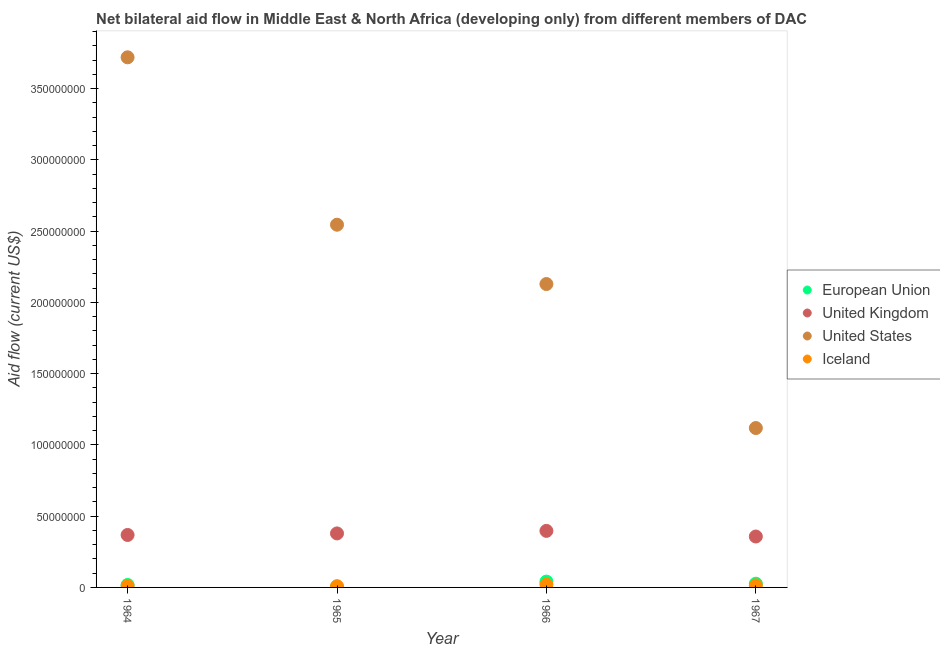What is the amount of aid given by eu in 1966?
Your response must be concise. 4.08e+06. Across all years, what is the maximum amount of aid given by us?
Your response must be concise. 3.72e+08. Across all years, what is the minimum amount of aid given by us?
Ensure brevity in your answer.  1.12e+08. In which year was the amount of aid given by us maximum?
Your answer should be very brief. 1964. In which year was the amount of aid given by uk minimum?
Your response must be concise. 1967. What is the total amount of aid given by us in the graph?
Make the answer very short. 9.51e+08. What is the difference between the amount of aid given by uk in 1964 and that in 1967?
Keep it short and to the point. 1.08e+06. What is the difference between the amount of aid given by uk in 1966 and the amount of aid given by us in 1964?
Your response must be concise. -3.32e+08. What is the average amount of aid given by iceland per year?
Make the answer very short. 1.36e+06. In the year 1967, what is the difference between the amount of aid given by us and amount of aid given by uk?
Your response must be concise. 7.61e+07. In how many years, is the amount of aid given by iceland greater than 140000000 US$?
Ensure brevity in your answer.  0. What is the ratio of the amount of aid given by uk in 1964 to that in 1965?
Offer a very short reply. 0.97. Is the amount of aid given by uk in 1965 less than that in 1967?
Your answer should be very brief. No. Is the difference between the amount of aid given by us in 1965 and 1966 greater than the difference between the amount of aid given by iceland in 1965 and 1966?
Offer a very short reply. Yes. What is the difference between the highest and the second highest amount of aid given by us?
Give a very brief answer. 1.17e+08. What is the difference between the highest and the lowest amount of aid given by eu?
Offer a very short reply. 3.86e+06. In how many years, is the amount of aid given by uk greater than the average amount of aid given by uk taken over all years?
Keep it short and to the point. 2. Is the sum of the amount of aid given by us in 1964 and 1965 greater than the maximum amount of aid given by iceland across all years?
Ensure brevity in your answer.  Yes. Is it the case that in every year, the sum of the amount of aid given by eu and amount of aid given by uk is greater than the amount of aid given by us?
Your answer should be very brief. No. Does the amount of aid given by iceland monotonically increase over the years?
Offer a very short reply. No. Is the amount of aid given by uk strictly less than the amount of aid given by us over the years?
Make the answer very short. Yes. How many dotlines are there?
Provide a short and direct response. 4. Are the values on the major ticks of Y-axis written in scientific E-notation?
Offer a very short reply. No. Does the graph contain grids?
Your answer should be very brief. No. Where does the legend appear in the graph?
Provide a succinct answer. Center right. How many legend labels are there?
Provide a succinct answer. 4. How are the legend labels stacked?
Your response must be concise. Vertical. What is the title of the graph?
Your response must be concise. Net bilateral aid flow in Middle East & North Africa (developing only) from different members of DAC. Does "Arable land" appear as one of the legend labels in the graph?
Keep it short and to the point. No. What is the label or title of the Y-axis?
Offer a terse response. Aid flow (current US$). What is the Aid flow (current US$) in European Union in 1964?
Provide a succinct answer. 1.71e+06. What is the Aid flow (current US$) in United Kingdom in 1964?
Offer a very short reply. 3.68e+07. What is the Aid flow (current US$) of United States in 1964?
Ensure brevity in your answer.  3.72e+08. What is the Aid flow (current US$) of Iceland in 1964?
Provide a succinct answer. 1.10e+06. What is the Aid flow (current US$) in European Union in 1965?
Provide a short and direct response. 2.20e+05. What is the Aid flow (current US$) of United Kingdom in 1965?
Make the answer very short. 3.79e+07. What is the Aid flow (current US$) in United States in 1965?
Your response must be concise. 2.55e+08. What is the Aid flow (current US$) in Iceland in 1965?
Make the answer very short. 8.70e+05. What is the Aid flow (current US$) of European Union in 1966?
Keep it short and to the point. 4.08e+06. What is the Aid flow (current US$) of United Kingdom in 1966?
Keep it short and to the point. 3.97e+07. What is the Aid flow (current US$) of United States in 1966?
Your answer should be very brief. 2.13e+08. What is the Aid flow (current US$) in Iceland in 1966?
Offer a very short reply. 2.01e+06. What is the Aid flow (current US$) in European Union in 1967?
Your answer should be very brief. 2.62e+06. What is the Aid flow (current US$) of United Kingdom in 1967?
Your response must be concise. 3.57e+07. What is the Aid flow (current US$) in United States in 1967?
Make the answer very short. 1.12e+08. What is the Aid flow (current US$) in Iceland in 1967?
Your response must be concise. 1.44e+06. Across all years, what is the maximum Aid flow (current US$) in European Union?
Provide a succinct answer. 4.08e+06. Across all years, what is the maximum Aid flow (current US$) of United Kingdom?
Offer a very short reply. 3.97e+07. Across all years, what is the maximum Aid flow (current US$) of United States?
Your response must be concise. 3.72e+08. Across all years, what is the maximum Aid flow (current US$) in Iceland?
Give a very brief answer. 2.01e+06. Across all years, what is the minimum Aid flow (current US$) of United Kingdom?
Provide a succinct answer. 3.57e+07. Across all years, what is the minimum Aid flow (current US$) in United States?
Offer a very short reply. 1.12e+08. Across all years, what is the minimum Aid flow (current US$) in Iceland?
Offer a terse response. 8.70e+05. What is the total Aid flow (current US$) in European Union in the graph?
Provide a succinct answer. 8.63e+06. What is the total Aid flow (current US$) in United Kingdom in the graph?
Make the answer very short. 1.50e+08. What is the total Aid flow (current US$) in United States in the graph?
Offer a very short reply. 9.51e+08. What is the total Aid flow (current US$) of Iceland in the graph?
Keep it short and to the point. 5.42e+06. What is the difference between the Aid flow (current US$) in European Union in 1964 and that in 1965?
Make the answer very short. 1.49e+06. What is the difference between the Aid flow (current US$) in United Kingdom in 1964 and that in 1965?
Ensure brevity in your answer.  -1.09e+06. What is the difference between the Aid flow (current US$) of United States in 1964 and that in 1965?
Provide a short and direct response. 1.17e+08. What is the difference between the Aid flow (current US$) of Iceland in 1964 and that in 1965?
Offer a very short reply. 2.30e+05. What is the difference between the Aid flow (current US$) of European Union in 1964 and that in 1966?
Offer a terse response. -2.37e+06. What is the difference between the Aid flow (current US$) of United Kingdom in 1964 and that in 1966?
Offer a very short reply. -2.87e+06. What is the difference between the Aid flow (current US$) of United States in 1964 and that in 1966?
Your response must be concise. 1.59e+08. What is the difference between the Aid flow (current US$) of Iceland in 1964 and that in 1966?
Offer a very short reply. -9.10e+05. What is the difference between the Aid flow (current US$) of European Union in 1964 and that in 1967?
Your answer should be compact. -9.10e+05. What is the difference between the Aid flow (current US$) in United Kingdom in 1964 and that in 1967?
Your answer should be compact. 1.08e+06. What is the difference between the Aid flow (current US$) in United States in 1964 and that in 1967?
Make the answer very short. 2.60e+08. What is the difference between the Aid flow (current US$) in European Union in 1965 and that in 1966?
Offer a terse response. -3.86e+06. What is the difference between the Aid flow (current US$) of United Kingdom in 1965 and that in 1966?
Keep it short and to the point. -1.78e+06. What is the difference between the Aid flow (current US$) in United States in 1965 and that in 1966?
Provide a succinct answer. 4.16e+07. What is the difference between the Aid flow (current US$) of Iceland in 1965 and that in 1966?
Give a very brief answer. -1.14e+06. What is the difference between the Aid flow (current US$) in European Union in 1965 and that in 1967?
Give a very brief answer. -2.40e+06. What is the difference between the Aid flow (current US$) in United Kingdom in 1965 and that in 1967?
Offer a terse response. 2.17e+06. What is the difference between the Aid flow (current US$) of United States in 1965 and that in 1967?
Offer a terse response. 1.43e+08. What is the difference between the Aid flow (current US$) of Iceland in 1965 and that in 1967?
Ensure brevity in your answer.  -5.70e+05. What is the difference between the Aid flow (current US$) in European Union in 1966 and that in 1967?
Offer a terse response. 1.46e+06. What is the difference between the Aid flow (current US$) in United Kingdom in 1966 and that in 1967?
Ensure brevity in your answer.  3.95e+06. What is the difference between the Aid flow (current US$) of United States in 1966 and that in 1967?
Your response must be concise. 1.01e+08. What is the difference between the Aid flow (current US$) in Iceland in 1966 and that in 1967?
Your answer should be very brief. 5.70e+05. What is the difference between the Aid flow (current US$) in European Union in 1964 and the Aid flow (current US$) in United Kingdom in 1965?
Make the answer very short. -3.62e+07. What is the difference between the Aid flow (current US$) in European Union in 1964 and the Aid flow (current US$) in United States in 1965?
Your response must be concise. -2.53e+08. What is the difference between the Aid flow (current US$) of European Union in 1964 and the Aid flow (current US$) of Iceland in 1965?
Your answer should be compact. 8.40e+05. What is the difference between the Aid flow (current US$) in United Kingdom in 1964 and the Aid flow (current US$) in United States in 1965?
Make the answer very short. -2.18e+08. What is the difference between the Aid flow (current US$) of United Kingdom in 1964 and the Aid flow (current US$) of Iceland in 1965?
Give a very brief answer. 3.59e+07. What is the difference between the Aid flow (current US$) of United States in 1964 and the Aid flow (current US$) of Iceland in 1965?
Provide a short and direct response. 3.71e+08. What is the difference between the Aid flow (current US$) of European Union in 1964 and the Aid flow (current US$) of United Kingdom in 1966?
Provide a short and direct response. -3.80e+07. What is the difference between the Aid flow (current US$) in European Union in 1964 and the Aid flow (current US$) in United States in 1966?
Give a very brief answer. -2.11e+08. What is the difference between the Aid flow (current US$) in European Union in 1964 and the Aid flow (current US$) in Iceland in 1966?
Give a very brief answer. -3.00e+05. What is the difference between the Aid flow (current US$) in United Kingdom in 1964 and the Aid flow (current US$) in United States in 1966?
Your response must be concise. -1.76e+08. What is the difference between the Aid flow (current US$) in United Kingdom in 1964 and the Aid flow (current US$) in Iceland in 1966?
Provide a short and direct response. 3.48e+07. What is the difference between the Aid flow (current US$) in United States in 1964 and the Aid flow (current US$) in Iceland in 1966?
Make the answer very short. 3.70e+08. What is the difference between the Aid flow (current US$) of European Union in 1964 and the Aid flow (current US$) of United Kingdom in 1967?
Offer a very short reply. -3.40e+07. What is the difference between the Aid flow (current US$) in European Union in 1964 and the Aid flow (current US$) in United States in 1967?
Provide a succinct answer. -1.10e+08. What is the difference between the Aid flow (current US$) in United Kingdom in 1964 and the Aid flow (current US$) in United States in 1967?
Give a very brief answer. -7.50e+07. What is the difference between the Aid flow (current US$) in United Kingdom in 1964 and the Aid flow (current US$) in Iceland in 1967?
Offer a terse response. 3.54e+07. What is the difference between the Aid flow (current US$) of United States in 1964 and the Aid flow (current US$) of Iceland in 1967?
Make the answer very short. 3.71e+08. What is the difference between the Aid flow (current US$) in European Union in 1965 and the Aid flow (current US$) in United Kingdom in 1966?
Make the answer very short. -3.95e+07. What is the difference between the Aid flow (current US$) of European Union in 1965 and the Aid flow (current US$) of United States in 1966?
Your answer should be compact. -2.13e+08. What is the difference between the Aid flow (current US$) of European Union in 1965 and the Aid flow (current US$) of Iceland in 1966?
Ensure brevity in your answer.  -1.79e+06. What is the difference between the Aid flow (current US$) in United Kingdom in 1965 and the Aid flow (current US$) in United States in 1966?
Your answer should be very brief. -1.75e+08. What is the difference between the Aid flow (current US$) in United Kingdom in 1965 and the Aid flow (current US$) in Iceland in 1966?
Your answer should be very brief. 3.59e+07. What is the difference between the Aid flow (current US$) of United States in 1965 and the Aid flow (current US$) of Iceland in 1966?
Your answer should be very brief. 2.53e+08. What is the difference between the Aid flow (current US$) of European Union in 1965 and the Aid flow (current US$) of United Kingdom in 1967?
Ensure brevity in your answer.  -3.55e+07. What is the difference between the Aid flow (current US$) in European Union in 1965 and the Aid flow (current US$) in United States in 1967?
Your answer should be very brief. -1.12e+08. What is the difference between the Aid flow (current US$) of European Union in 1965 and the Aid flow (current US$) of Iceland in 1967?
Provide a short and direct response. -1.22e+06. What is the difference between the Aid flow (current US$) in United Kingdom in 1965 and the Aid flow (current US$) in United States in 1967?
Make the answer very short. -7.40e+07. What is the difference between the Aid flow (current US$) of United Kingdom in 1965 and the Aid flow (current US$) of Iceland in 1967?
Offer a terse response. 3.65e+07. What is the difference between the Aid flow (current US$) in United States in 1965 and the Aid flow (current US$) in Iceland in 1967?
Your answer should be very brief. 2.53e+08. What is the difference between the Aid flow (current US$) of European Union in 1966 and the Aid flow (current US$) of United Kingdom in 1967?
Give a very brief answer. -3.16e+07. What is the difference between the Aid flow (current US$) of European Union in 1966 and the Aid flow (current US$) of United States in 1967?
Provide a short and direct response. -1.08e+08. What is the difference between the Aid flow (current US$) in European Union in 1966 and the Aid flow (current US$) in Iceland in 1967?
Offer a terse response. 2.64e+06. What is the difference between the Aid flow (current US$) of United Kingdom in 1966 and the Aid flow (current US$) of United States in 1967?
Make the answer very short. -7.22e+07. What is the difference between the Aid flow (current US$) of United Kingdom in 1966 and the Aid flow (current US$) of Iceland in 1967?
Keep it short and to the point. 3.82e+07. What is the difference between the Aid flow (current US$) in United States in 1966 and the Aid flow (current US$) in Iceland in 1967?
Your response must be concise. 2.11e+08. What is the average Aid flow (current US$) of European Union per year?
Offer a terse response. 2.16e+06. What is the average Aid flow (current US$) in United Kingdom per year?
Give a very brief answer. 3.75e+07. What is the average Aid flow (current US$) in United States per year?
Ensure brevity in your answer.  2.38e+08. What is the average Aid flow (current US$) in Iceland per year?
Keep it short and to the point. 1.36e+06. In the year 1964, what is the difference between the Aid flow (current US$) of European Union and Aid flow (current US$) of United Kingdom?
Your answer should be compact. -3.51e+07. In the year 1964, what is the difference between the Aid flow (current US$) of European Union and Aid flow (current US$) of United States?
Make the answer very short. -3.70e+08. In the year 1964, what is the difference between the Aid flow (current US$) of European Union and Aid flow (current US$) of Iceland?
Ensure brevity in your answer.  6.10e+05. In the year 1964, what is the difference between the Aid flow (current US$) in United Kingdom and Aid flow (current US$) in United States?
Keep it short and to the point. -3.35e+08. In the year 1964, what is the difference between the Aid flow (current US$) of United Kingdom and Aid flow (current US$) of Iceland?
Your answer should be very brief. 3.57e+07. In the year 1964, what is the difference between the Aid flow (current US$) of United States and Aid flow (current US$) of Iceland?
Keep it short and to the point. 3.71e+08. In the year 1965, what is the difference between the Aid flow (current US$) in European Union and Aid flow (current US$) in United Kingdom?
Give a very brief answer. -3.77e+07. In the year 1965, what is the difference between the Aid flow (current US$) of European Union and Aid flow (current US$) of United States?
Offer a terse response. -2.54e+08. In the year 1965, what is the difference between the Aid flow (current US$) in European Union and Aid flow (current US$) in Iceland?
Make the answer very short. -6.50e+05. In the year 1965, what is the difference between the Aid flow (current US$) in United Kingdom and Aid flow (current US$) in United States?
Your response must be concise. -2.17e+08. In the year 1965, what is the difference between the Aid flow (current US$) of United Kingdom and Aid flow (current US$) of Iceland?
Your response must be concise. 3.70e+07. In the year 1965, what is the difference between the Aid flow (current US$) in United States and Aid flow (current US$) in Iceland?
Your answer should be very brief. 2.54e+08. In the year 1966, what is the difference between the Aid flow (current US$) of European Union and Aid flow (current US$) of United Kingdom?
Offer a terse response. -3.56e+07. In the year 1966, what is the difference between the Aid flow (current US$) of European Union and Aid flow (current US$) of United States?
Keep it short and to the point. -2.09e+08. In the year 1966, what is the difference between the Aid flow (current US$) of European Union and Aid flow (current US$) of Iceland?
Keep it short and to the point. 2.07e+06. In the year 1966, what is the difference between the Aid flow (current US$) in United Kingdom and Aid flow (current US$) in United States?
Ensure brevity in your answer.  -1.73e+08. In the year 1966, what is the difference between the Aid flow (current US$) in United Kingdom and Aid flow (current US$) in Iceland?
Offer a terse response. 3.77e+07. In the year 1966, what is the difference between the Aid flow (current US$) in United States and Aid flow (current US$) in Iceland?
Keep it short and to the point. 2.11e+08. In the year 1967, what is the difference between the Aid flow (current US$) of European Union and Aid flow (current US$) of United Kingdom?
Your answer should be very brief. -3.31e+07. In the year 1967, what is the difference between the Aid flow (current US$) of European Union and Aid flow (current US$) of United States?
Offer a very short reply. -1.09e+08. In the year 1967, what is the difference between the Aid flow (current US$) of European Union and Aid flow (current US$) of Iceland?
Make the answer very short. 1.18e+06. In the year 1967, what is the difference between the Aid flow (current US$) of United Kingdom and Aid flow (current US$) of United States?
Ensure brevity in your answer.  -7.61e+07. In the year 1967, what is the difference between the Aid flow (current US$) of United Kingdom and Aid flow (current US$) of Iceland?
Offer a very short reply. 3.43e+07. In the year 1967, what is the difference between the Aid flow (current US$) of United States and Aid flow (current US$) of Iceland?
Your answer should be very brief. 1.10e+08. What is the ratio of the Aid flow (current US$) in European Union in 1964 to that in 1965?
Offer a very short reply. 7.77. What is the ratio of the Aid flow (current US$) of United Kingdom in 1964 to that in 1965?
Keep it short and to the point. 0.97. What is the ratio of the Aid flow (current US$) of United States in 1964 to that in 1965?
Provide a short and direct response. 1.46. What is the ratio of the Aid flow (current US$) of Iceland in 1964 to that in 1965?
Offer a very short reply. 1.26. What is the ratio of the Aid flow (current US$) of European Union in 1964 to that in 1966?
Keep it short and to the point. 0.42. What is the ratio of the Aid flow (current US$) in United Kingdom in 1964 to that in 1966?
Keep it short and to the point. 0.93. What is the ratio of the Aid flow (current US$) of United States in 1964 to that in 1966?
Give a very brief answer. 1.75. What is the ratio of the Aid flow (current US$) in Iceland in 1964 to that in 1966?
Provide a short and direct response. 0.55. What is the ratio of the Aid flow (current US$) in European Union in 1964 to that in 1967?
Ensure brevity in your answer.  0.65. What is the ratio of the Aid flow (current US$) in United Kingdom in 1964 to that in 1967?
Your answer should be compact. 1.03. What is the ratio of the Aid flow (current US$) in United States in 1964 to that in 1967?
Provide a short and direct response. 3.33. What is the ratio of the Aid flow (current US$) of Iceland in 1964 to that in 1967?
Keep it short and to the point. 0.76. What is the ratio of the Aid flow (current US$) in European Union in 1965 to that in 1966?
Offer a terse response. 0.05. What is the ratio of the Aid flow (current US$) of United Kingdom in 1965 to that in 1966?
Ensure brevity in your answer.  0.96. What is the ratio of the Aid flow (current US$) in United States in 1965 to that in 1966?
Provide a short and direct response. 1.2. What is the ratio of the Aid flow (current US$) in Iceland in 1965 to that in 1966?
Offer a terse response. 0.43. What is the ratio of the Aid flow (current US$) of European Union in 1965 to that in 1967?
Make the answer very short. 0.08. What is the ratio of the Aid flow (current US$) of United Kingdom in 1965 to that in 1967?
Your answer should be compact. 1.06. What is the ratio of the Aid flow (current US$) of United States in 1965 to that in 1967?
Your answer should be very brief. 2.28. What is the ratio of the Aid flow (current US$) in Iceland in 1965 to that in 1967?
Ensure brevity in your answer.  0.6. What is the ratio of the Aid flow (current US$) of European Union in 1966 to that in 1967?
Your answer should be very brief. 1.56. What is the ratio of the Aid flow (current US$) of United Kingdom in 1966 to that in 1967?
Give a very brief answer. 1.11. What is the ratio of the Aid flow (current US$) in United States in 1966 to that in 1967?
Provide a succinct answer. 1.9. What is the ratio of the Aid flow (current US$) in Iceland in 1966 to that in 1967?
Make the answer very short. 1.4. What is the difference between the highest and the second highest Aid flow (current US$) of European Union?
Make the answer very short. 1.46e+06. What is the difference between the highest and the second highest Aid flow (current US$) in United Kingdom?
Provide a short and direct response. 1.78e+06. What is the difference between the highest and the second highest Aid flow (current US$) in United States?
Your response must be concise. 1.17e+08. What is the difference between the highest and the second highest Aid flow (current US$) in Iceland?
Provide a succinct answer. 5.70e+05. What is the difference between the highest and the lowest Aid flow (current US$) of European Union?
Your answer should be very brief. 3.86e+06. What is the difference between the highest and the lowest Aid flow (current US$) of United Kingdom?
Provide a succinct answer. 3.95e+06. What is the difference between the highest and the lowest Aid flow (current US$) in United States?
Your response must be concise. 2.60e+08. What is the difference between the highest and the lowest Aid flow (current US$) of Iceland?
Keep it short and to the point. 1.14e+06. 